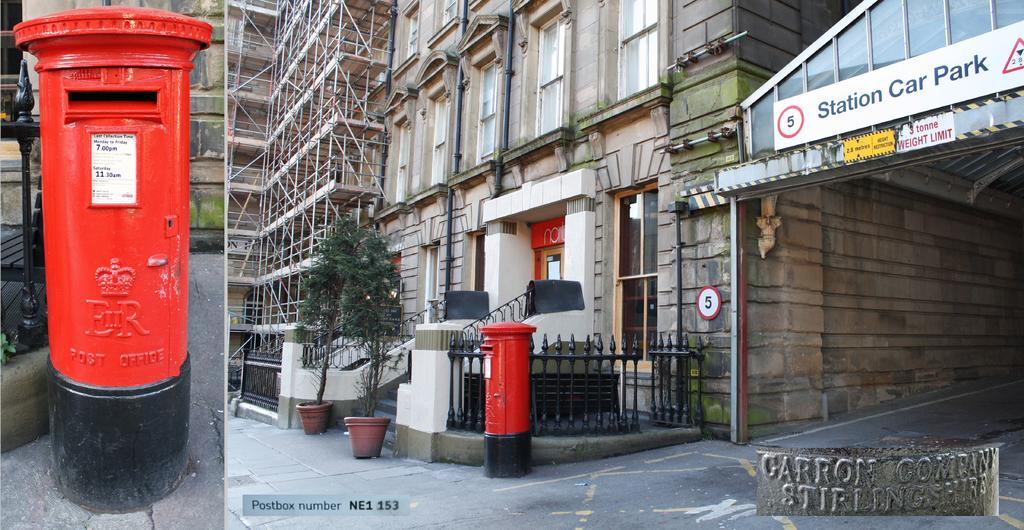Describe this image in one or two sentences. In this picture I can see a post box on the left side, in the middle there are trees and buildings. On the right side there is a board, at the bottom there is the text. It is a photo collage. 